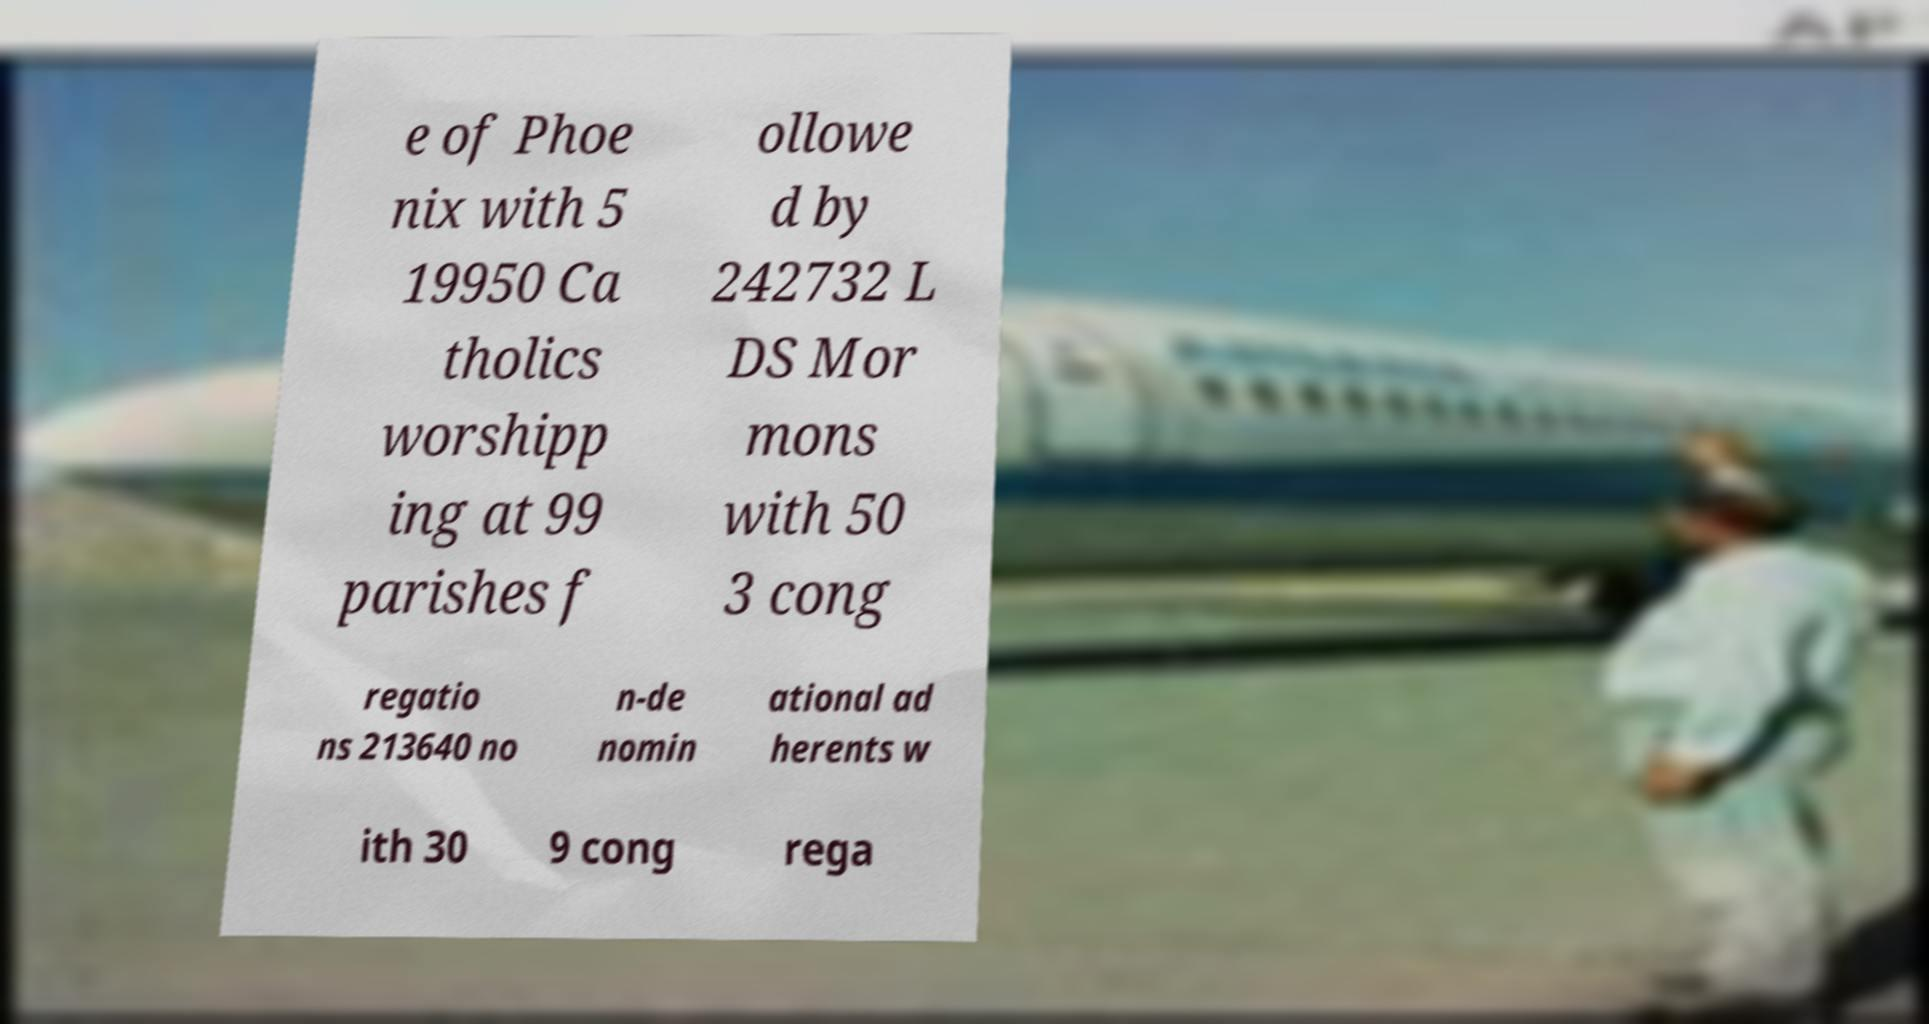There's text embedded in this image that I need extracted. Can you transcribe it verbatim? e of Phoe nix with 5 19950 Ca tholics worshipp ing at 99 parishes f ollowe d by 242732 L DS Mor mons with 50 3 cong regatio ns 213640 no n-de nomin ational ad herents w ith 30 9 cong rega 